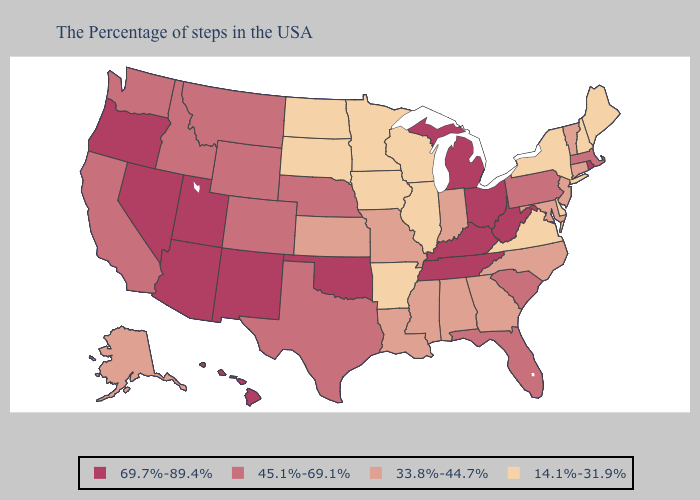What is the value of Illinois?
Give a very brief answer. 14.1%-31.9%. Name the states that have a value in the range 14.1%-31.9%?
Give a very brief answer. Maine, New Hampshire, New York, Delaware, Virginia, Wisconsin, Illinois, Arkansas, Minnesota, Iowa, South Dakota, North Dakota. Does the first symbol in the legend represent the smallest category?
Quick response, please. No. Name the states that have a value in the range 45.1%-69.1%?
Short answer required. Massachusetts, Pennsylvania, South Carolina, Florida, Nebraska, Texas, Wyoming, Colorado, Montana, Idaho, California, Washington. What is the lowest value in the USA?
Short answer required. 14.1%-31.9%. Does the map have missing data?
Answer briefly. No. How many symbols are there in the legend?
Keep it brief. 4. Does the map have missing data?
Write a very short answer. No. Name the states that have a value in the range 14.1%-31.9%?
Concise answer only. Maine, New Hampshire, New York, Delaware, Virginia, Wisconsin, Illinois, Arkansas, Minnesota, Iowa, South Dakota, North Dakota. Name the states that have a value in the range 69.7%-89.4%?
Concise answer only. Rhode Island, West Virginia, Ohio, Michigan, Kentucky, Tennessee, Oklahoma, New Mexico, Utah, Arizona, Nevada, Oregon, Hawaii. Name the states that have a value in the range 45.1%-69.1%?
Quick response, please. Massachusetts, Pennsylvania, South Carolina, Florida, Nebraska, Texas, Wyoming, Colorado, Montana, Idaho, California, Washington. Name the states that have a value in the range 45.1%-69.1%?
Answer briefly. Massachusetts, Pennsylvania, South Carolina, Florida, Nebraska, Texas, Wyoming, Colorado, Montana, Idaho, California, Washington. Name the states that have a value in the range 45.1%-69.1%?
Keep it brief. Massachusetts, Pennsylvania, South Carolina, Florida, Nebraska, Texas, Wyoming, Colorado, Montana, Idaho, California, Washington. Name the states that have a value in the range 33.8%-44.7%?
Short answer required. Vermont, Connecticut, New Jersey, Maryland, North Carolina, Georgia, Indiana, Alabama, Mississippi, Louisiana, Missouri, Kansas, Alaska. Name the states that have a value in the range 33.8%-44.7%?
Concise answer only. Vermont, Connecticut, New Jersey, Maryland, North Carolina, Georgia, Indiana, Alabama, Mississippi, Louisiana, Missouri, Kansas, Alaska. 